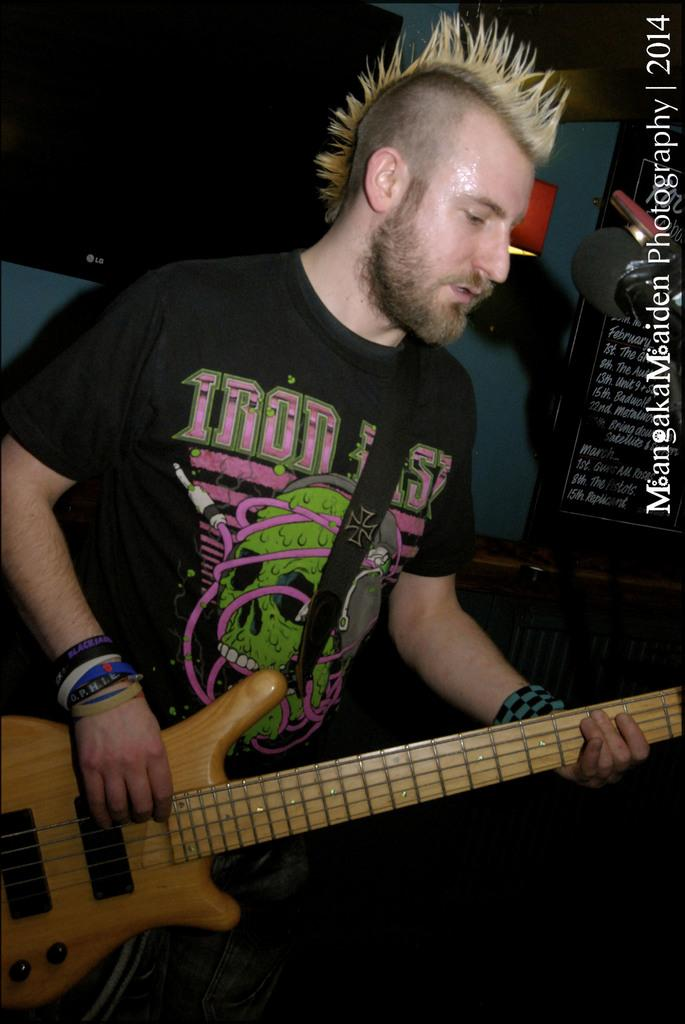What is the main subject of the image? There is a man in the image. What is the man doing in the image? The man is standing in the image. What object is the man holding in the image? The man is holding a guitar in the image. What type of glue can be seen on the guitar in the image? There is no glue present on the guitar in the image. How many ladybugs are crawling on the man's shirt in the image? There are no ladybugs present on the man's shirt in the image. 